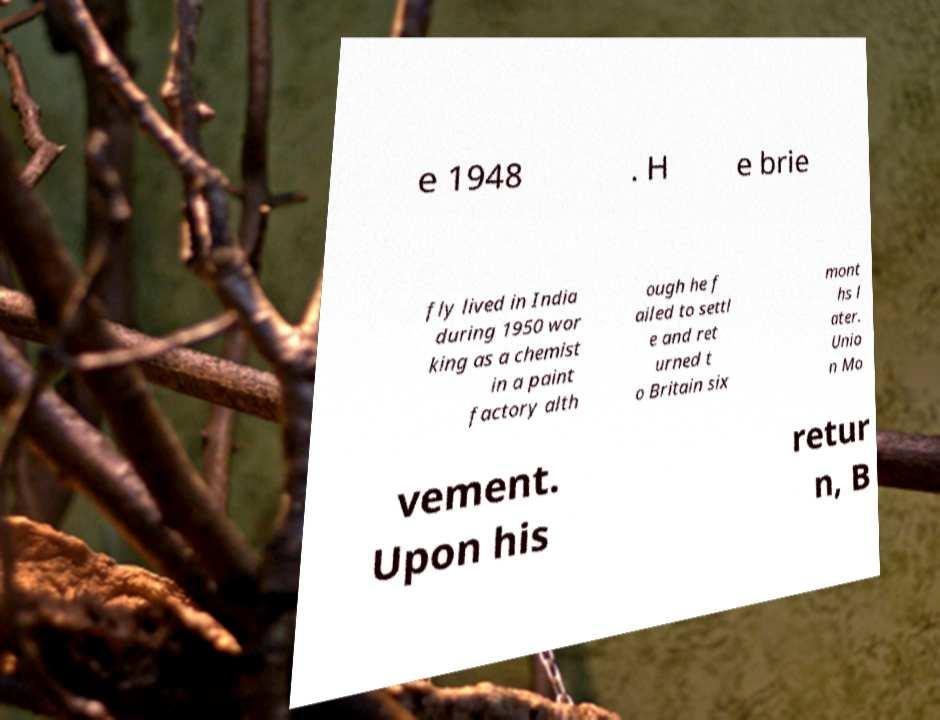Can you read and provide the text displayed in the image?This photo seems to have some interesting text. Can you extract and type it out for me? e 1948 . H e brie fly lived in India during 1950 wor king as a chemist in a paint factory alth ough he f ailed to settl e and ret urned t o Britain six mont hs l ater. Unio n Mo vement. Upon his retur n, B 